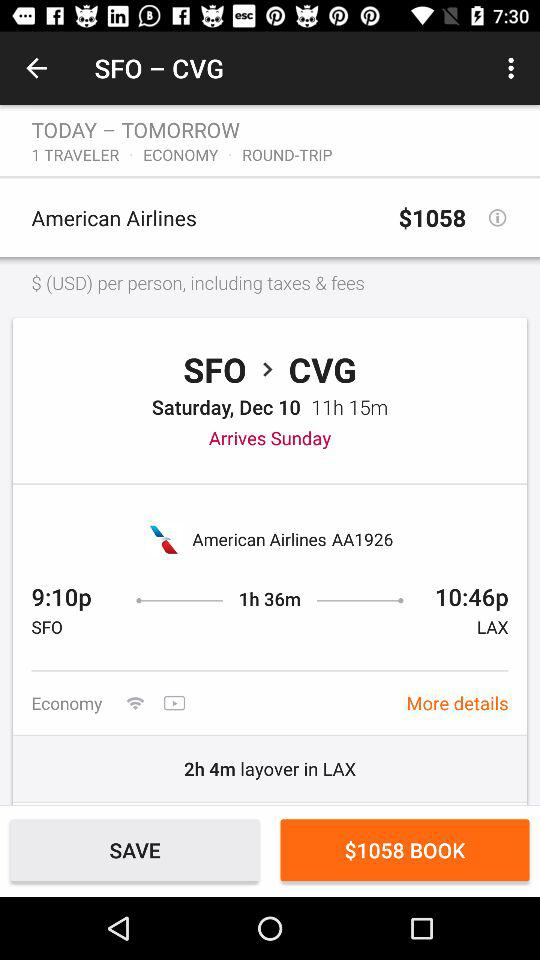What is the arrival time at LAX? The arrival time at LAX is 10:46 p.m. 